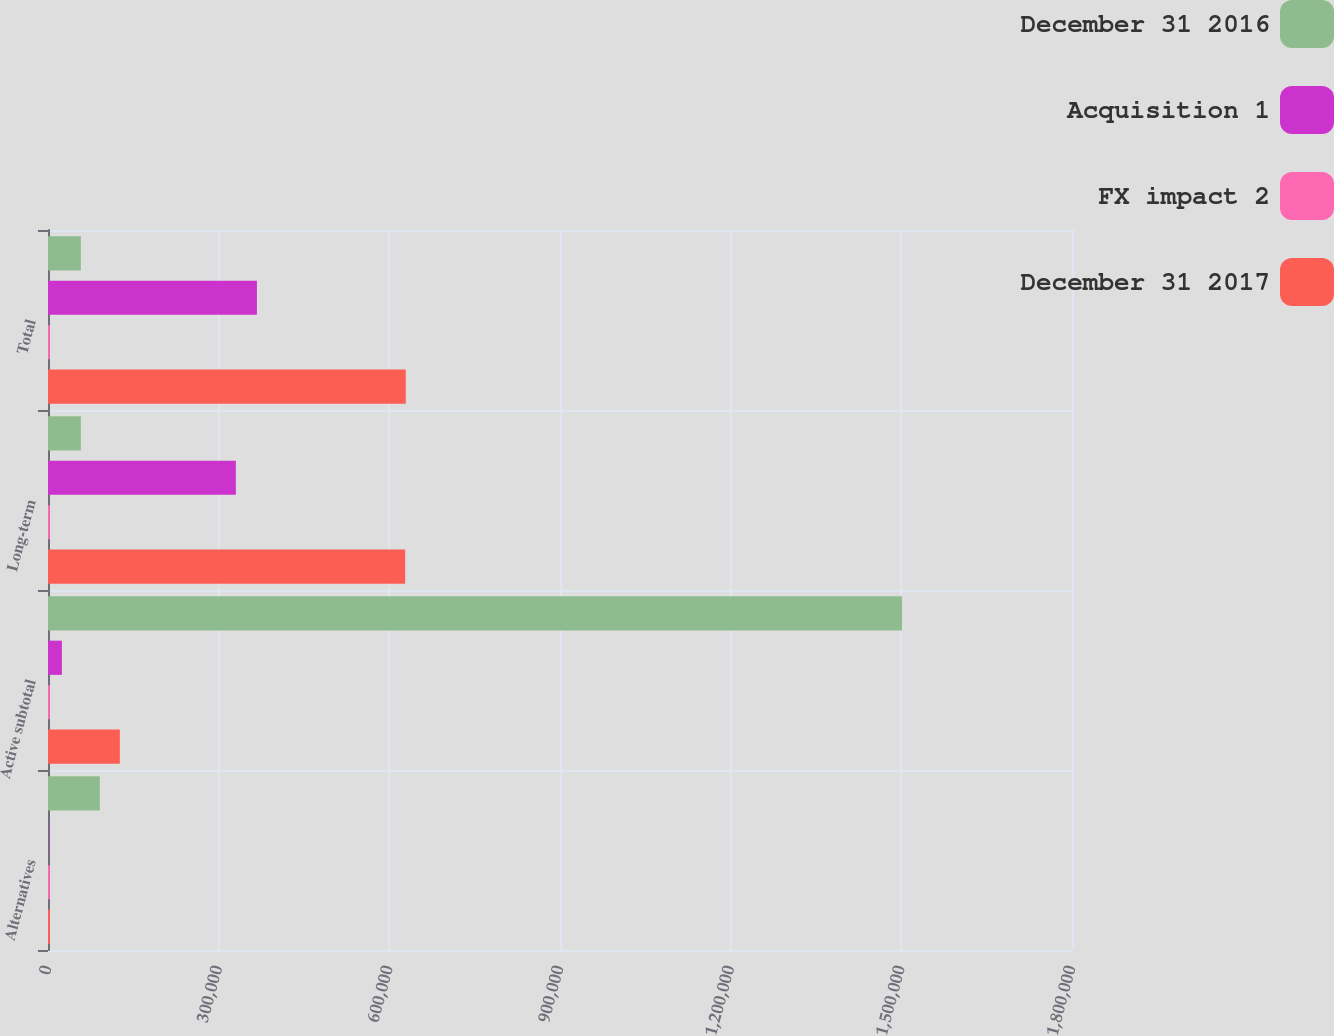<chart> <loc_0><loc_0><loc_500><loc_500><stacked_bar_chart><ecel><fcel>Alternatives<fcel>Active subtotal<fcel>Long-term<fcel>Total<nl><fcel>December 31 2016<fcel>91093<fcel>1.50105e+06<fcel>57771<fcel>57771<nl><fcel>Acquisition 1<fcel>667<fcel>24449<fcel>330240<fcel>367254<nl><fcel>FX impact 2<fcel>3264<fcel>3264<fcel>3264<fcel>3264<nl><fcel>December 31 2017<fcel>3479<fcel>126266<fcel>627867<fcel>628901<nl></chart> 